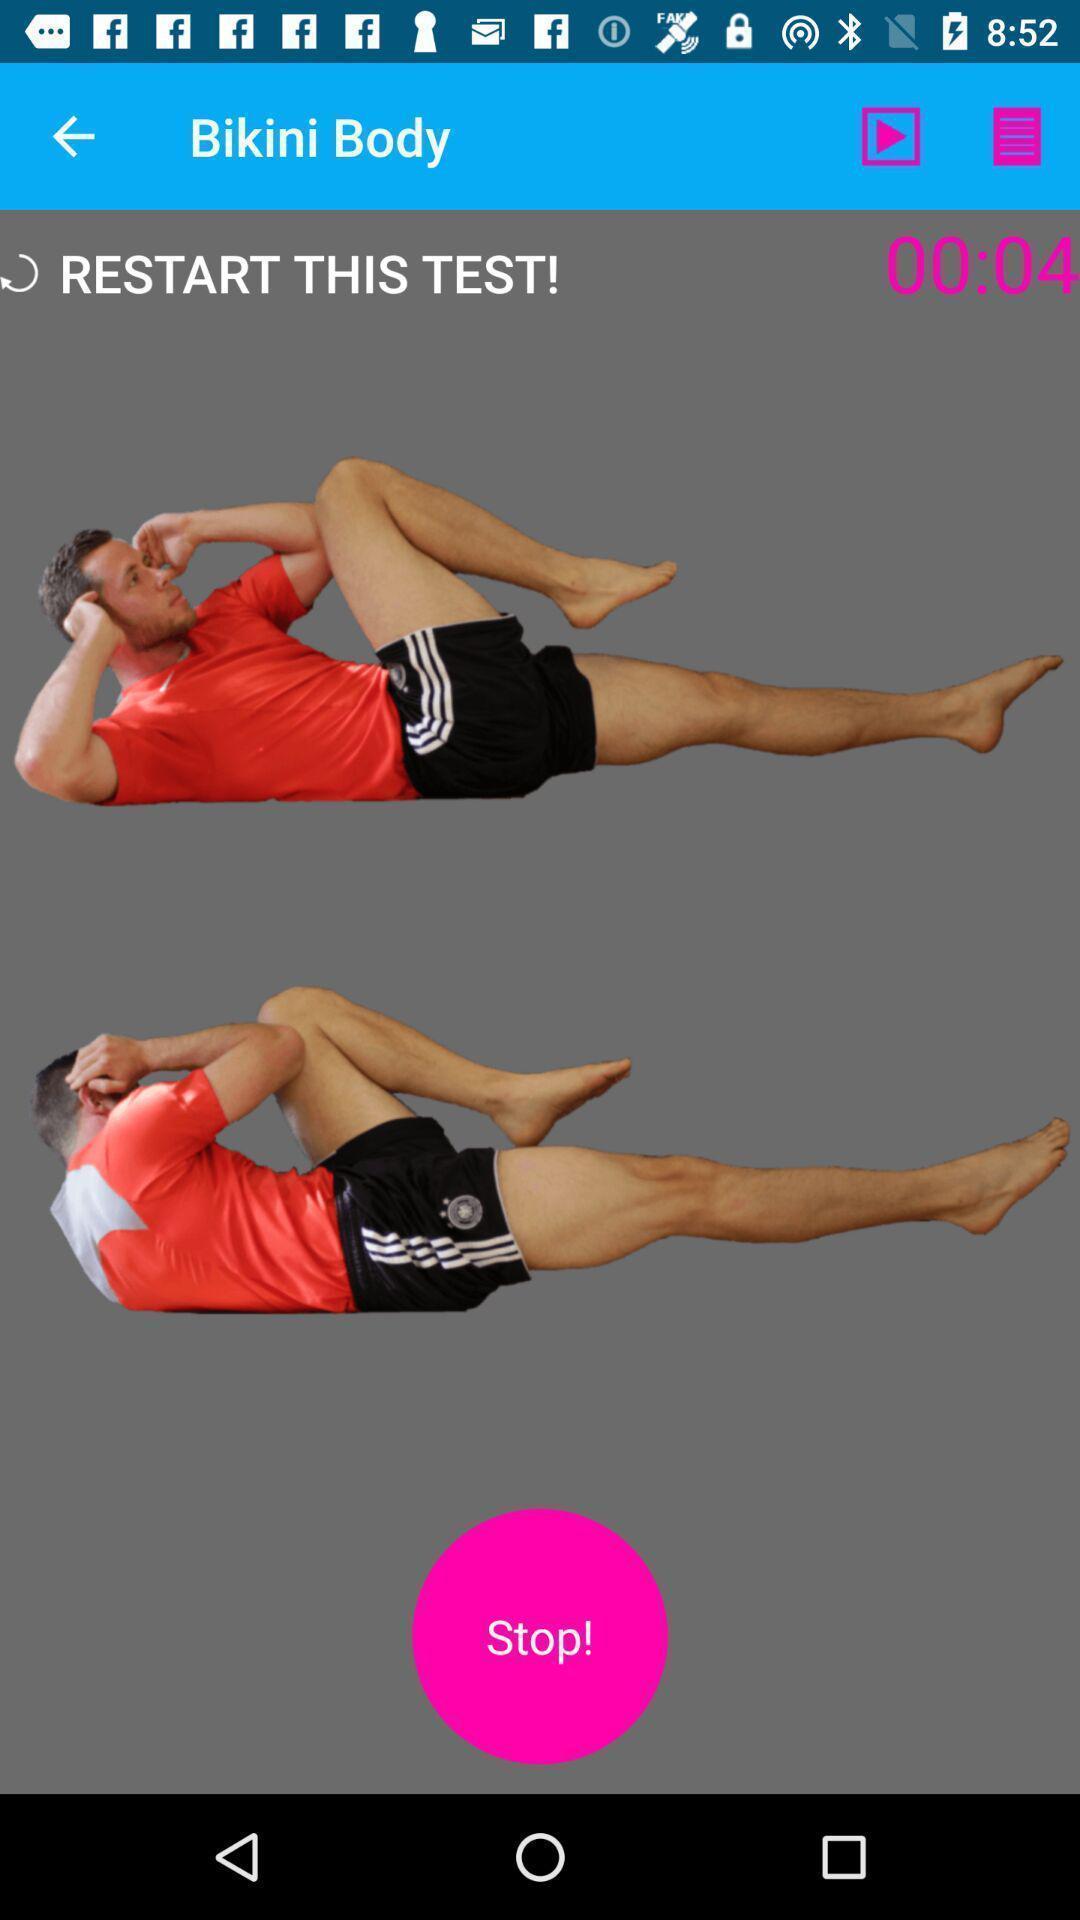Describe the visual elements of this screenshot. Timer and other controls are displaying in the healthcare app. 